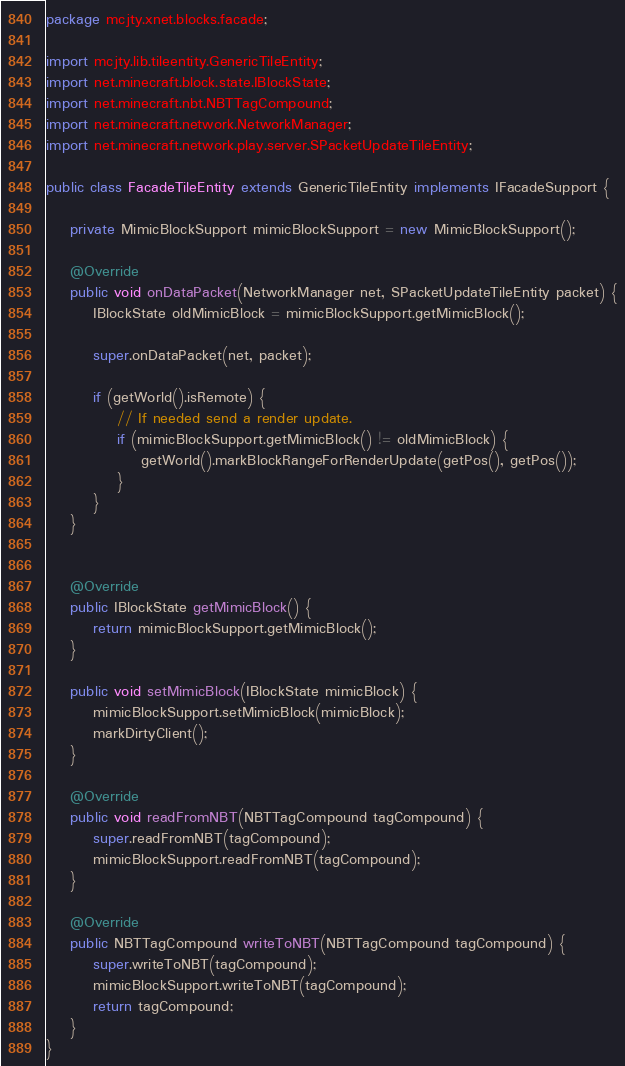<code> <loc_0><loc_0><loc_500><loc_500><_Java_>package mcjty.xnet.blocks.facade;

import mcjty.lib.tileentity.GenericTileEntity;
import net.minecraft.block.state.IBlockState;
import net.minecraft.nbt.NBTTagCompound;
import net.minecraft.network.NetworkManager;
import net.minecraft.network.play.server.SPacketUpdateTileEntity;

public class FacadeTileEntity extends GenericTileEntity implements IFacadeSupport {

    private MimicBlockSupport mimicBlockSupport = new MimicBlockSupport();

    @Override
    public void onDataPacket(NetworkManager net, SPacketUpdateTileEntity packet) {
        IBlockState oldMimicBlock = mimicBlockSupport.getMimicBlock();

        super.onDataPacket(net, packet);

        if (getWorld().isRemote) {
            // If needed send a render update.
            if (mimicBlockSupport.getMimicBlock() != oldMimicBlock) {
                getWorld().markBlockRangeForRenderUpdate(getPos(), getPos());
            }
        }
    }


    @Override
    public IBlockState getMimicBlock() {
        return mimicBlockSupport.getMimicBlock();
    }

    public void setMimicBlock(IBlockState mimicBlock) {
        mimicBlockSupport.setMimicBlock(mimicBlock);
        markDirtyClient();
    }

    @Override
    public void readFromNBT(NBTTagCompound tagCompound) {
        super.readFromNBT(tagCompound);
        mimicBlockSupport.readFromNBT(tagCompound);
    }

    @Override
    public NBTTagCompound writeToNBT(NBTTagCompound tagCompound) {
        super.writeToNBT(tagCompound);
        mimicBlockSupport.writeToNBT(tagCompound);
        return tagCompound;
    }
}
</code> 